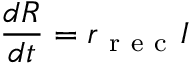Convert formula to latex. <formula><loc_0><loc_0><loc_500><loc_500>\frac { d R } { d t } = r _ { r e c } I</formula> 